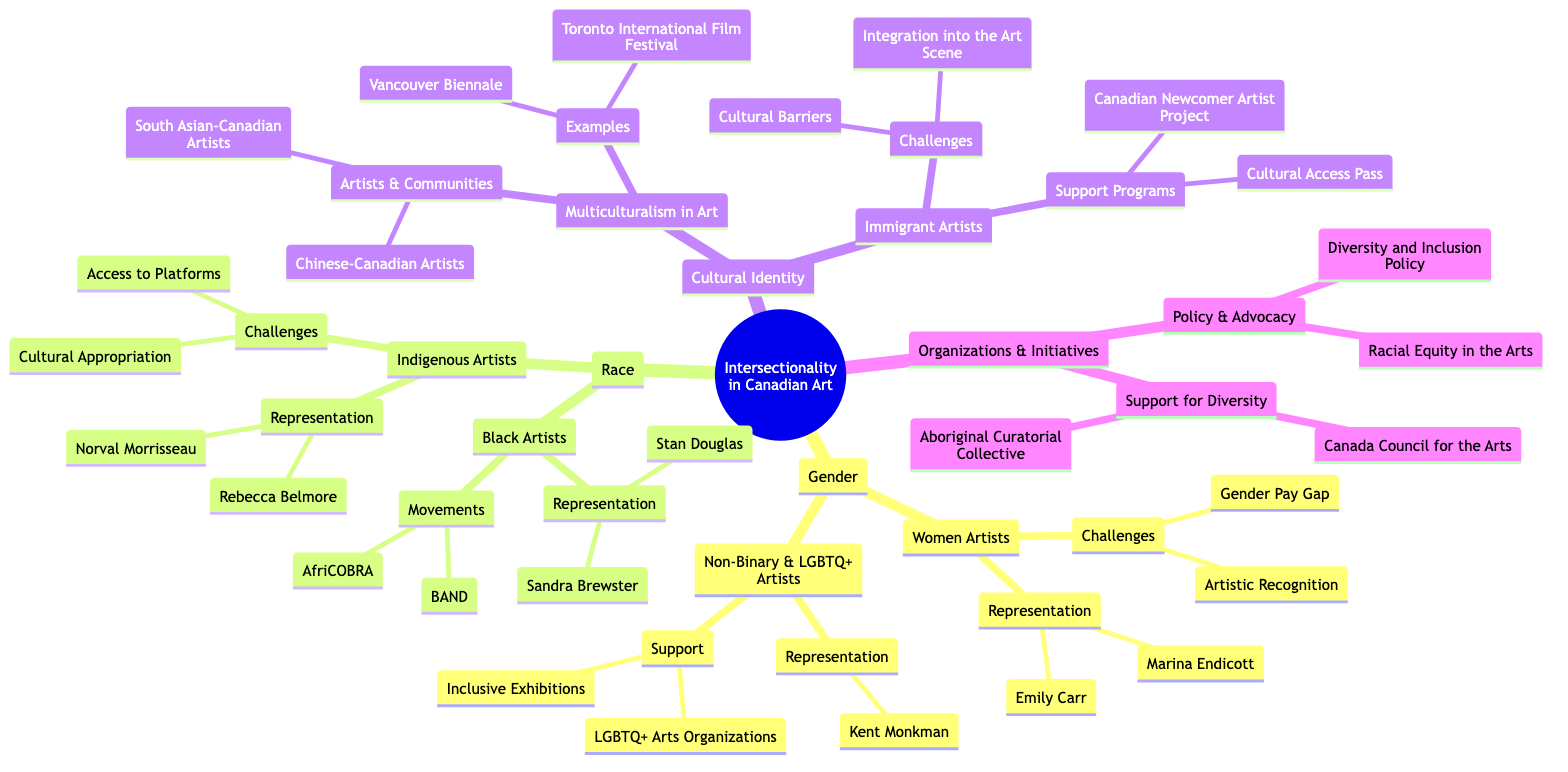What are two women artists mentioned in the diagram? The diagram lists Emily Carr and Marina Endicott as representatives under the "Women Artists" category. I directly locate the "Women Artists" node and identify the two names listed under "Representation".
Answer: Emily Carr, Marina Endicott What challenges do women artists face according to the diagram? The diagram specifies "Gender Pay Gap" and "Artistic Recognition" as challenges faced by women artists. I look under the "Women Artists" node to find the "Challenges" section for these two specific issues.
Answer: Gender Pay Gap, Artistic Recognition How many organizations are listed under "Support for Diversity"? The diagram shows two organizations listed under "Support for Diversity" – Canada Council for the Arts and Aboriginal Curatorial Collective. I count the organizations in that section to find the total number.
Answer: 2 Who is a notable Indigenous artist represented in the diagram? The diagram identifies Norval Morrisseau and Rebecca Belmore under the "Indigenous Artists" category. I focus on the "Representation" node to pick one of the names given.
Answer: Norval Morrisseau What types of support are available for Non-Binary and LGBTQ+ artists as per the diagram? The diagram mentions "LGBTQ+ Arts Organizations" and "Inclusive Exhibitions" as supports for Non-Binary and LGBTQ+ artists. I refer to the "Support" node under "Non-Binary & LGBTQ+ Artists" to find this information.
Answer: LGBTQ+ Arts Organizations, Inclusive Exhibitions Which two movements are associated with Black artists? "AfriCOBRA" and "Black Artists’ Networks In Dialogue (BAND)" are identified in the diagram under the "Movements" section for Black Artists. I look under the "Black Artists" node to find these movements enumerated.
Answer: AfriCOBRA, BAND What challenges do immigrant artists face according to the diagram? The diagram states that immigrant artists experience "Cultural Barriers" and "Integration into the Art Scene" as challenges. I examine the "Challenges" listed under the "Immigrant Artists" category to extract these difficulties.
Answer: Cultural Barriers, Integration into the Art Scene What policy is mentioned regarding advocacy in the arts? The diagram lists "Diversity and Inclusion Policy" under the "Policy & Advocacy" section. I locate this node under "Organizations & Initiatives" to identify the relevant policy indicated.
Answer: Diversity and Inclusion Policy 